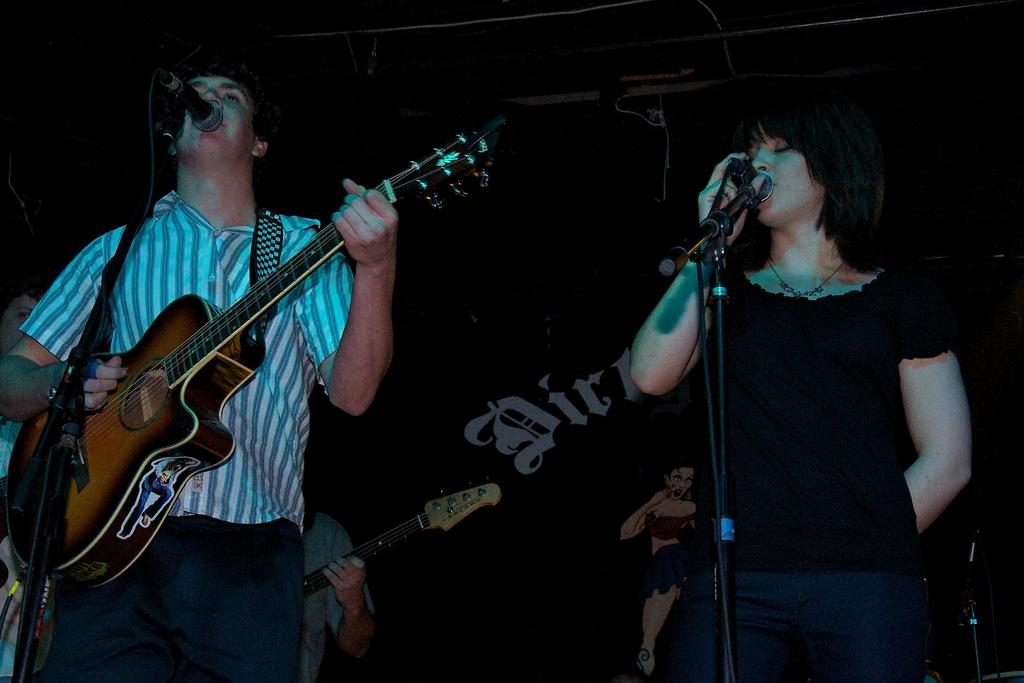What are the two people in the image doing? The woman and the man are singing in the image. What are they using to amplify their voices? They are singing into a microphone. What instrument is the man playing? The man is playing the guitar. How many chairs are visible in the image? There is no chair present in the image. Is there a hook hanging from the ceiling in the image? There is no hook hanging from the ceiling in the image. 